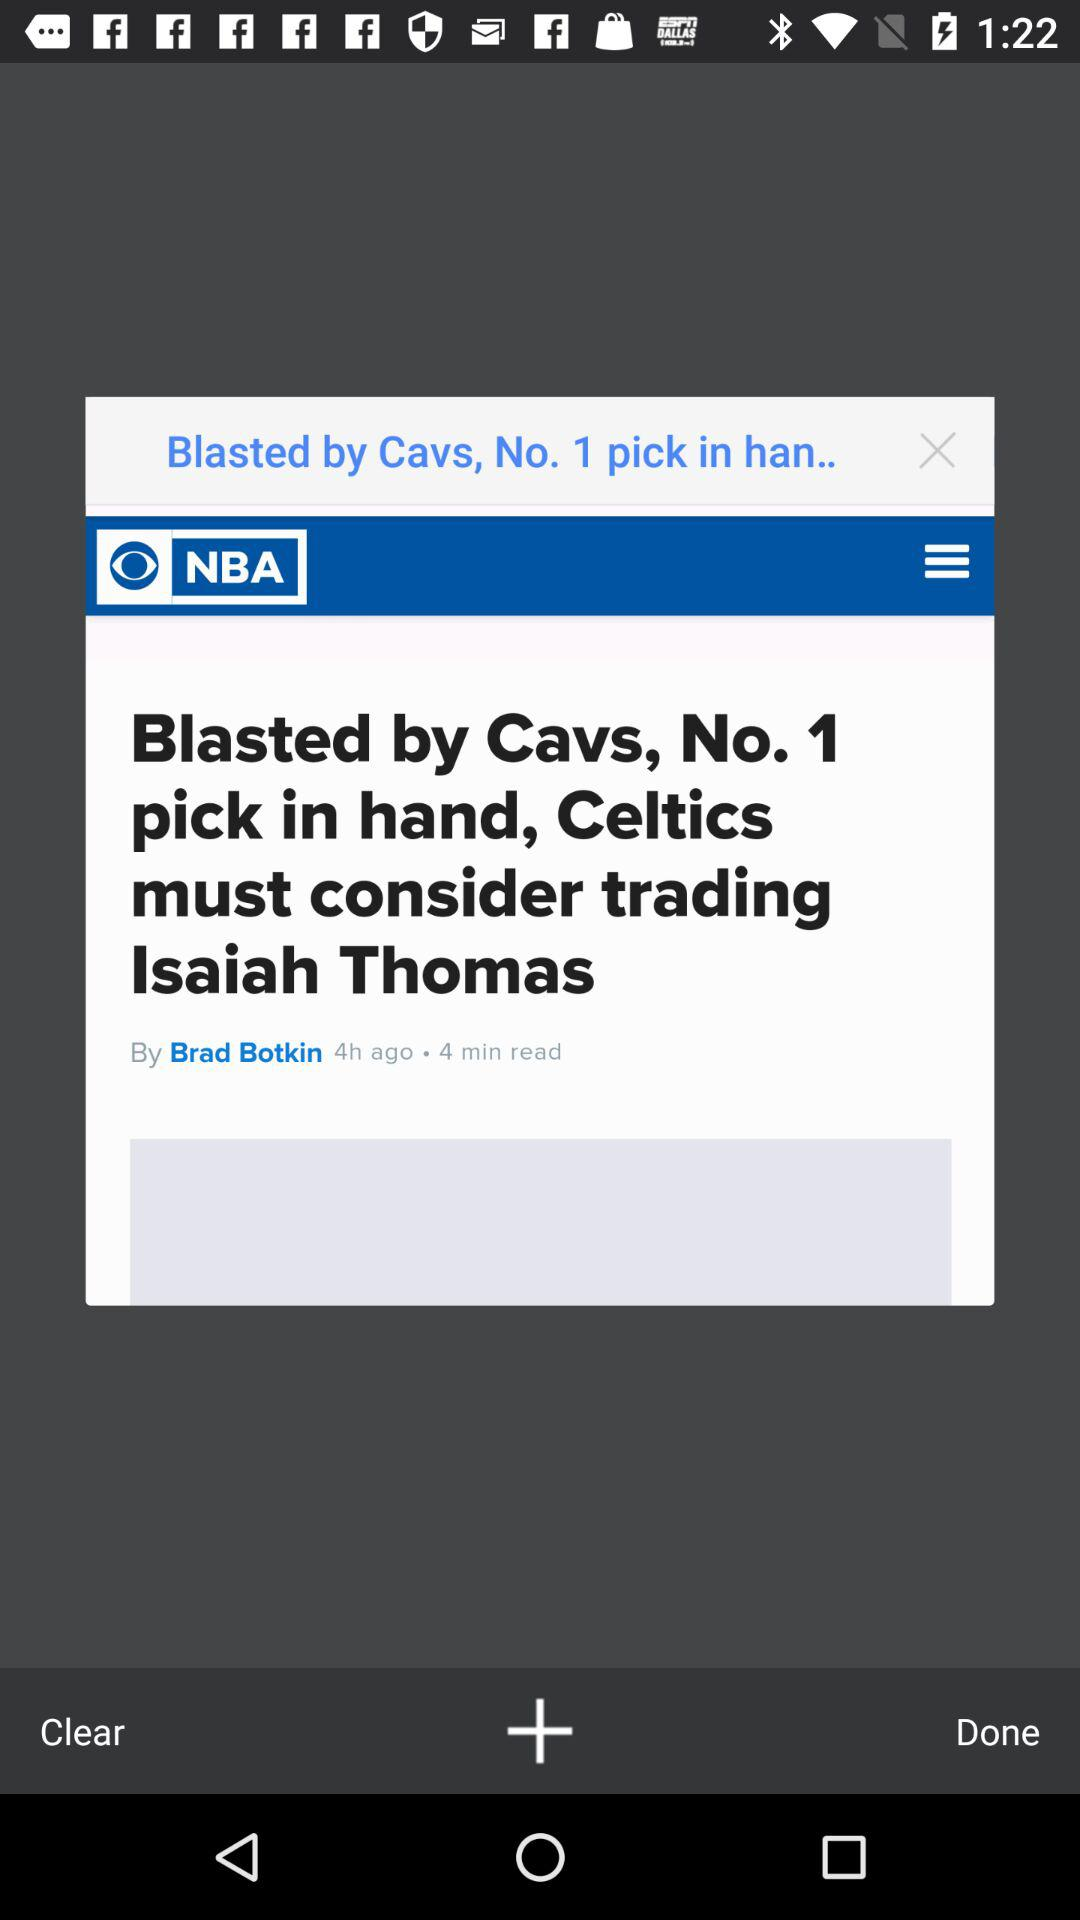When was it updated? It was updated 4 hours ago. 